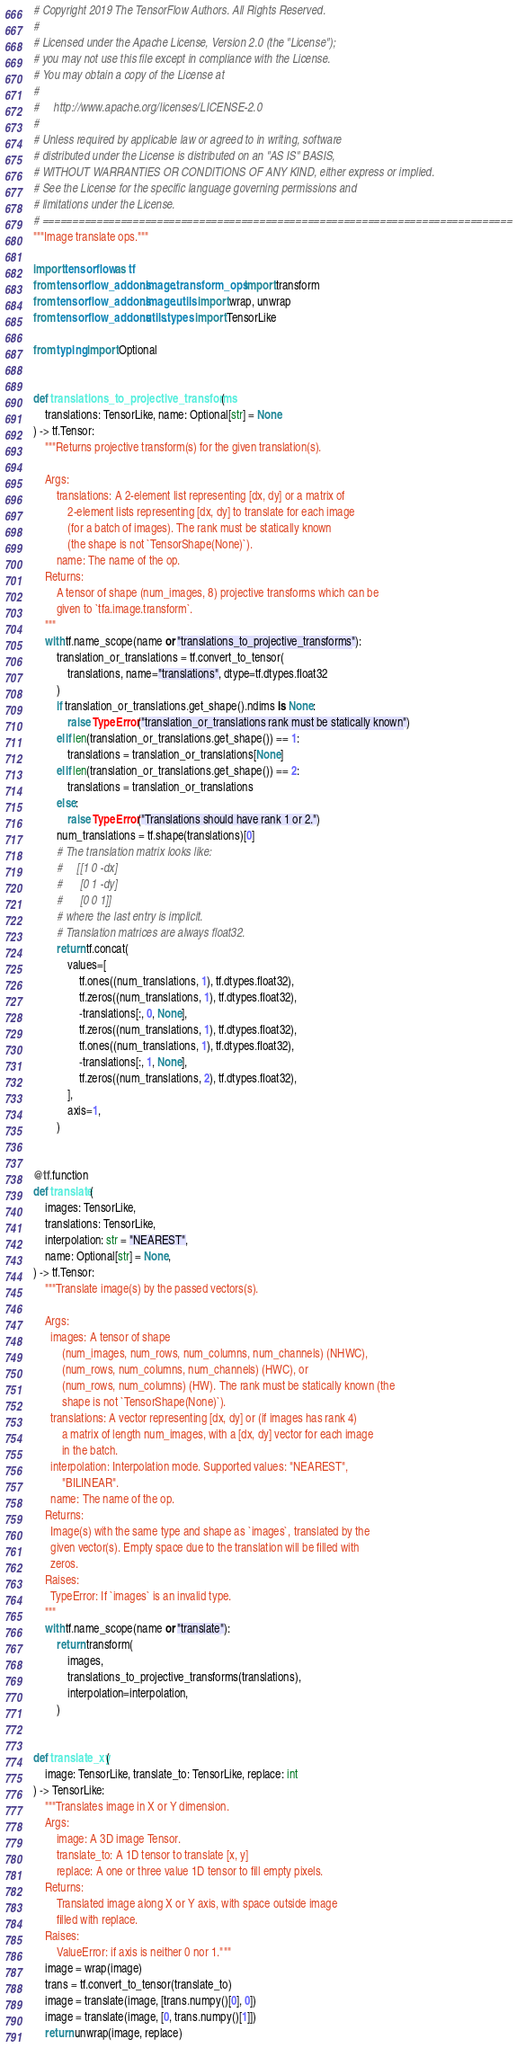<code> <loc_0><loc_0><loc_500><loc_500><_Python_># Copyright 2019 The TensorFlow Authors. All Rights Reserved.
#
# Licensed under the Apache License, Version 2.0 (the "License");
# you may not use this file except in compliance with the License.
# You may obtain a copy of the License at
#
#     http://www.apache.org/licenses/LICENSE-2.0
#
# Unless required by applicable law or agreed to in writing, software
# distributed under the License is distributed on an "AS IS" BASIS,
# WITHOUT WARRANTIES OR CONDITIONS OF ANY KIND, either express or implied.
# See the License for the specific language governing permissions and
# limitations under the License.
# ==============================================================================
"""Image translate ops."""

import tensorflow as tf
from tensorflow_addons.image.transform_ops import transform
from tensorflow_addons.image.utils import wrap, unwrap
from tensorflow_addons.utils.types import TensorLike

from typing import Optional


def translations_to_projective_transforms(
    translations: TensorLike, name: Optional[str] = None
) -> tf.Tensor:
    """Returns projective transform(s) for the given translation(s).

    Args:
        translations: A 2-element list representing [dx, dy] or a matrix of
            2-element lists representing [dx, dy] to translate for each image
            (for a batch of images). The rank must be statically known
            (the shape is not `TensorShape(None)`).
        name: The name of the op.
    Returns:
        A tensor of shape (num_images, 8) projective transforms which can be
        given to `tfa.image.transform`.
    """
    with tf.name_scope(name or "translations_to_projective_transforms"):
        translation_or_translations = tf.convert_to_tensor(
            translations, name="translations", dtype=tf.dtypes.float32
        )
        if translation_or_translations.get_shape().ndims is None:
            raise TypeError("translation_or_translations rank must be statically known")
        elif len(translation_or_translations.get_shape()) == 1:
            translations = translation_or_translations[None]
        elif len(translation_or_translations.get_shape()) == 2:
            translations = translation_or_translations
        else:
            raise TypeError("Translations should have rank 1 or 2.")
        num_translations = tf.shape(translations)[0]
        # The translation matrix looks like:
        #     [[1 0 -dx]
        #      [0 1 -dy]
        #      [0 0 1]]
        # where the last entry is implicit.
        # Translation matrices are always float32.
        return tf.concat(
            values=[
                tf.ones((num_translations, 1), tf.dtypes.float32),
                tf.zeros((num_translations, 1), tf.dtypes.float32),
                -translations[:, 0, None],
                tf.zeros((num_translations, 1), tf.dtypes.float32),
                tf.ones((num_translations, 1), tf.dtypes.float32),
                -translations[:, 1, None],
                tf.zeros((num_translations, 2), tf.dtypes.float32),
            ],
            axis=1,
        )


@tf.function
def translate(
    images: TensorLike,
    translations: TensorLike,
    interpolation: str = "NEAREST",
    name: Optional[str] = None,
) -> tf.Tensor:
    """Translate image(s) by the passed vectors(s).

    Args:
      images: A tensor of shape
          (num_images, num_rows, num_columns, num_channels) (NHWC),
          (num_rows, num_columns, num_channels) (HWC), or
          (num_rows, num_columns) (HW). The rank must be statically known (the
          shape is not `TensorShape(None)`).
      translations: A vector representing [dx, dy] or (if images has rank 4)
          a matrix of length num_images, with a [dx, dy] vector for each image
          in the batch.
      interpolation: Interpolation mode. Supported values: "NEAREST",
          "BILINEAR".
      name: The name of the op.
    Returns:
      Image(s) with the same type and shape as `images`, translated by the
      given vector(s). Empty space due to the translation will be filled with
      zeros.
    Raises:
      TypeError: If `images` is an invalid type.
    """
    with tf.name_scope(name or "translate"):
        return transform(
            images,
            translations_to_projective_transforms(translations),
            interpolation=interpolation,
        )


def translate_xy(
    image: TensorLike, translate_to: TensorLike, replace: int
) -> TensorLike:
    """Translates image in X or Y dimension.
    Args:
        image: A 3D image Tensor.
        translate_to: A 1D tensor to translate [x, y]
        replace: A one or three value 1D tensor to fill empty pixels.
    Returns:
        Translated image along X or Y axis, with space outside image
        filled with replace.
    Raises:
        ValueError: if axis is neither 0 nor 1."""
    image = wrap(image)
    trans = tf.convert_to_tensor(translate_to)
    image = translate(image, [trans.numpy()[0], 0])
    image = translate(image, [0, trans.numpy()[1]])
    return unwrap(image, replace)
</code> 